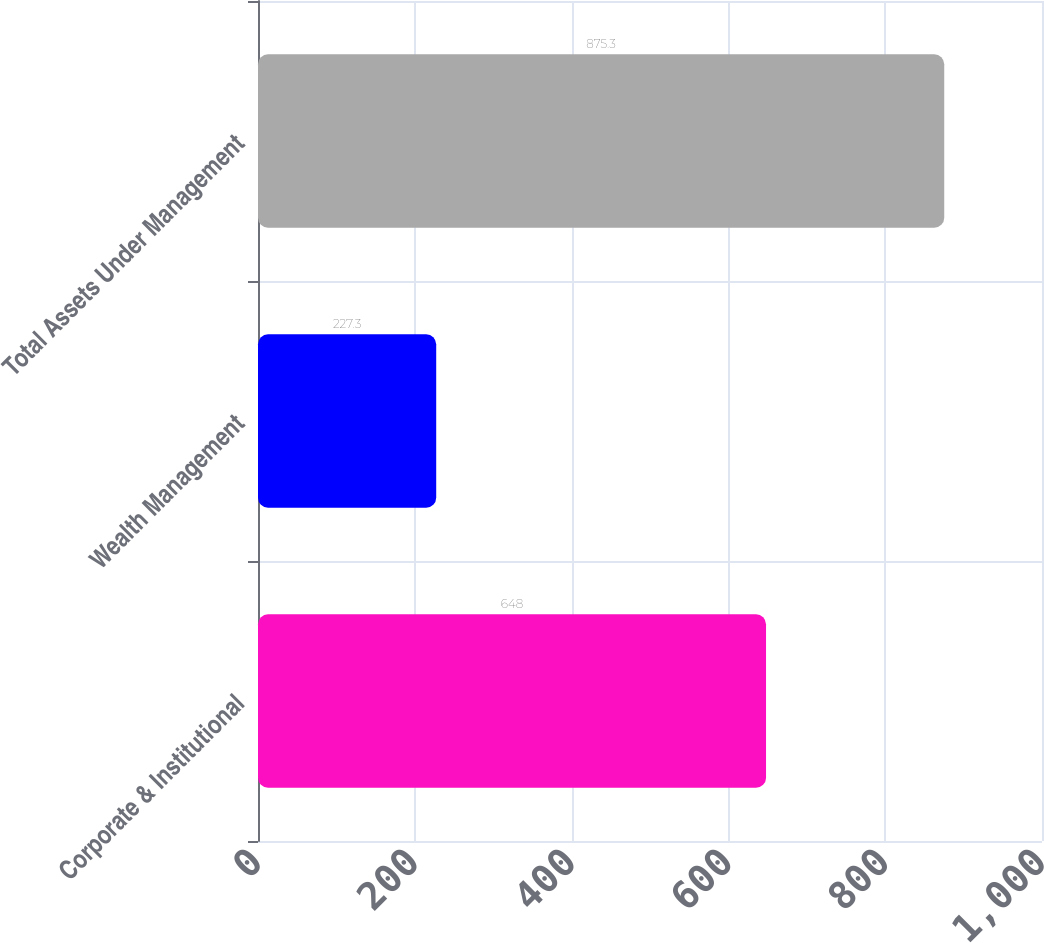<chart> <loc_0><loc_0><loc_500><loc_500><bar_chart><fcel>Corporate & Institutional<fcel>Wealth Management<fcel>Total Assets Under Management<nl><fcel>648<fcel>227.3<fcel>875.3<nl></chart> 